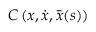Convert formula to latex. <formula><loc_0><loc_0><loc_500><loc_500>C \left ( x , \dot { x } , \bar { x } ( s ) \right )</formula> 